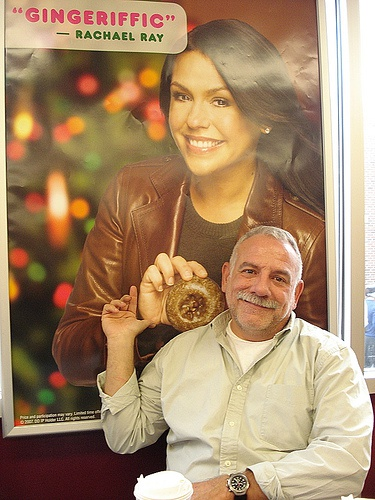Describe the objects in this image and their specific colors. I can see people in tan and beige tones, donut in tan, olive, and maroon tones, and cup in tan, white, and black tones in this image. 